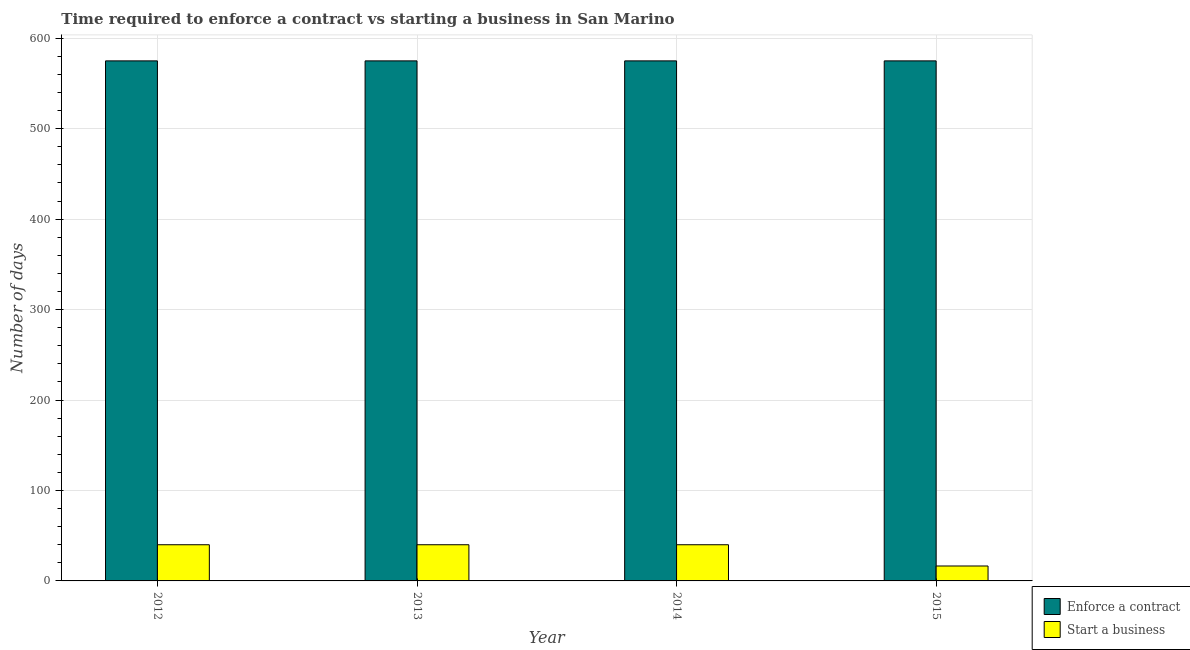How many different coloured bars are there?
Make the answer very short. 2. How many groups of bars are there?
Keep it short and to the point. 4. Are the number of bars per tick equal to the number of legend labels?
Offer a terse response. Yes. Are the number of bars on each tick of the X-axis equal?
Offer a very short reply. Yes. In how many cases, is the number of bars for a given year not equal to the number of legend labels?
Provide a short and direct response. 0. What is the number of days to start a business in 2015?
Ensure brevity in your answer.  16.5. Across all years, what is the maximum number of days to enforece a contract?
Ensure brevity in your answer.  575. Across all years, what is the minimum number of days to enforece a contract?
Make the answer very short. 575. In which year was the number of days to start a business maximum?
Offer a terse response. 2012. In which year was the number of days to enforece a contract minimum?
Ensure brevity in your answer.  2012. What is the total number of days to start a business in the graph?
Make the answer very short. 136.5. What is the difference between the number of days to enforece a contract in 2014 and the number of days to start a business in 2015?
Keep it short and to the point. 0. What is the average number of days to start a business per year?
Your answer should be compact. 34.12. In the year 2015, what is the difference between the number of days to start a business and number of days to enforece a contract?
Make the answer very short. 0. Is the number of days to enforece a contract in 2013 less than that in 2014?
Your answer should be very brief. No. What is the difference between the highest and the lowest number of days to start a business?
Your answer should be very brief. 23.5. In how many years, is the number of days to start a business greater than the average number of days to start a business taken over all years?
Ensure brevity in your answer.  3. Is the sum of the number of days to enforece a contract in 2012 and 2014 greater than the maximum number of days to start a business across all years?
Offer a very short reply. Yes. What does the 2nd bar from the left in 2012 represents?
Your answer should be very brief. Start a business. What does the 2nd bar from the right in 2012 represents?
Offer a terse response. Enforce a contract. How many bars are there?
Offer a very short reply. 8. Are the values on the major ticks of Y-axis written in scientific E-notation?
Your answer should be very brief. No. Where does the legend appear in the graph?
Keep it short and to the point. Bottom right. What is the title of the graph?
Provide a short and direct response. Time required to enforce a contract vs starting a business in San Marino. What is the label or title of the Y-axis?
Offer a terse response. Number of days. What is the Number of days of Enforce a contract in 2012?
Your answer should be compact. 575. What is the Number of days in Start a business in 2012?
Offer a terse response. 40. What is the Number of days in Enforce a contract in 2013?
Your answer should be very brief. 575. What is the Number of days of Start a business in 2013?
Your answer should be very brief. 40. What is the Number of days of Enforce a contract in 2014?
Provide a succinct answer. 575. What is the Number of days in Start a business in 2014?
Keep it short and to the point. 40. What is the Number of days of Enforce a contract in 2015?
Offer a very short reply. 575. Across all years, what is the maximum Number of days in Enforce a contract?
Provide a short and direct response. 575. Across all years, what is the maximum Number of days in Start a business?
Your answer should be compact. 40. Across all years, what is the minimum Number of days of Enforce a contract?
Make the answer very short. 575. Across all years, what is the minimum Number of days in Start a business?
Your response must be concise. 16.5. What is the total Number of days of Enforce a contract in the graph?
Provide a succinct answer. 2300. What is the total Number of days in Start a business in the graph?
Make the answer very short. 136.5. What is the difference between the Number of days of Start a business in 2012 and that in 2013?
Ensure brevity in your answer.  0. What is the difference between the Number of days of Enforce a contract in 2012 and that in 2014?
Give a very brief answer. 0. What is the difference between the Number of days in Start a business in 2012 and that in 2014?
Give a very brief answer. 0. What is the difference between the Number of days of Start a business in 2012 and that in 2015?
Ensure brevity in your answer.  23.5. What is the difference between the Number of days of Start a business in 2013 and that in 2014?
Offer a very short reply. 0. What is the difference between the Number of days of Enforce a contract in 2014 and that in 2015?
Provide a short and direct response. 0. What is the difference between the Number of days of Start a business in 2014 and that in 2015?
Provide a succinct answer. 23.5. What is the difference between the Number of days of Enforce a contract in 2012 and the Number of days of Start a business in 2013?
Give a very brief answer. 535. What is the difference between the Number of days in Enforce a contract in 2012 and the Number of days in Start a business in 2014?
Offer a terse response. 535. What is the difference between the Number of days in Enforce a contract in 2012 and the Number of days in Start a business in 2015?
Offer a very short reply. 558.5. What is the difference between the Number of days of Enforce a contract in 2013 and the Number of days of Start a business in 2014?
Ensure brevity in your answer.  535. What is the difference between the Number of days of Enforce a contract in 2013 and the Number of days of Start a business in 2015?
Provide a succinct answer. 558.5. What is the difference between the Number of days in Enforce a contract in 2014 and the Number of days in Start a business in 2015?
Offer a very short reply. 558.5. What is the average Number of days of Enforce a contract per year?
Offer a very short reply. 575. What is the average Number of days of Start a business per year?
Offer a terse response. 34.12. In the year 2012, what is the difference between the Number of days in Enforce a contract and Number of days in Start a business?
Keep it short and to the point. 535. In the year 2013, what is the difference between the Number of days in Enforce a contract and Number of days in Start a business?
Offer a terse response. 535. In the year 2014, what is the difference between the Number of days in Enforce a contract and Number of days in Start a business?
Provide a succinct answer. 535. In the year 2015, what is the difference between the Number of days of Enforce a contract and Number of days of Start a business?
Give a very brief answer. 558.5. What is the ratio of the Number of days of Enforce a contract in 2012 to that in 2014?
Ensure brevity in your answer.  1. What is the ratio of the Number of days of Start a business in 2012 to that in 2015?
Ensure brevity in your answer.  2.42. What is the ratio of the Number of days of Enforce a contract in 2013 to that in 2015?
Make the answer very short. 1. What is the ratio of the Number of days of Start a business in 2013 to that in 2015?
Your response must be concise. 2.42. What is the ratio of the Number of days of Enforce a contract in 2014 to that in 2015?
Your answer should be very brief. 1. What is the ratio of the Number of days in Start a business in 2014 to that in 2015?
Your response must be concise. 2.42. What is the difference between the highest and the second highest Number of days in Enforce a contract?
Provide a succinct answer. 0. What is the difference between the highest and the second highest Number of days of Start a business?
Provide a succinct answer. 0. What is the difference between the highest and the lowest Number of days of Enforce a contract?
Provide a short and direct response. 0. 